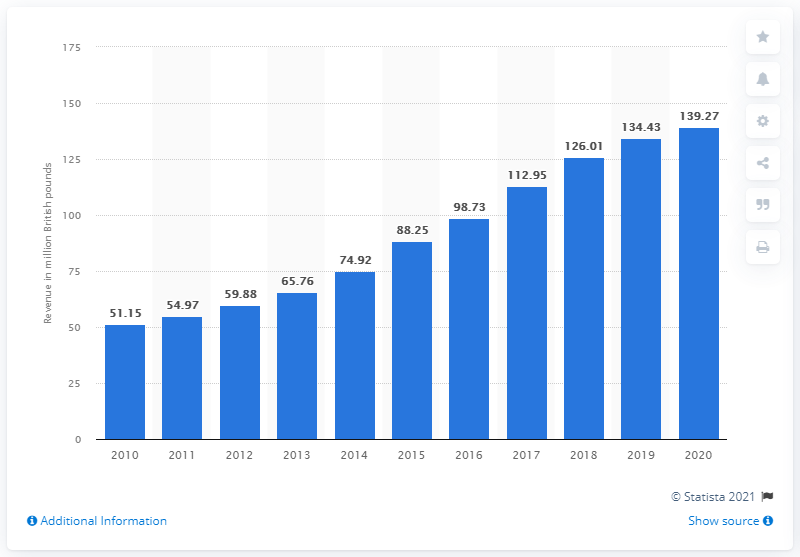Point out several critical features in this image. In 2020, Fortnum & Mason's annual turnover was approximately 139.27 million pounds. 